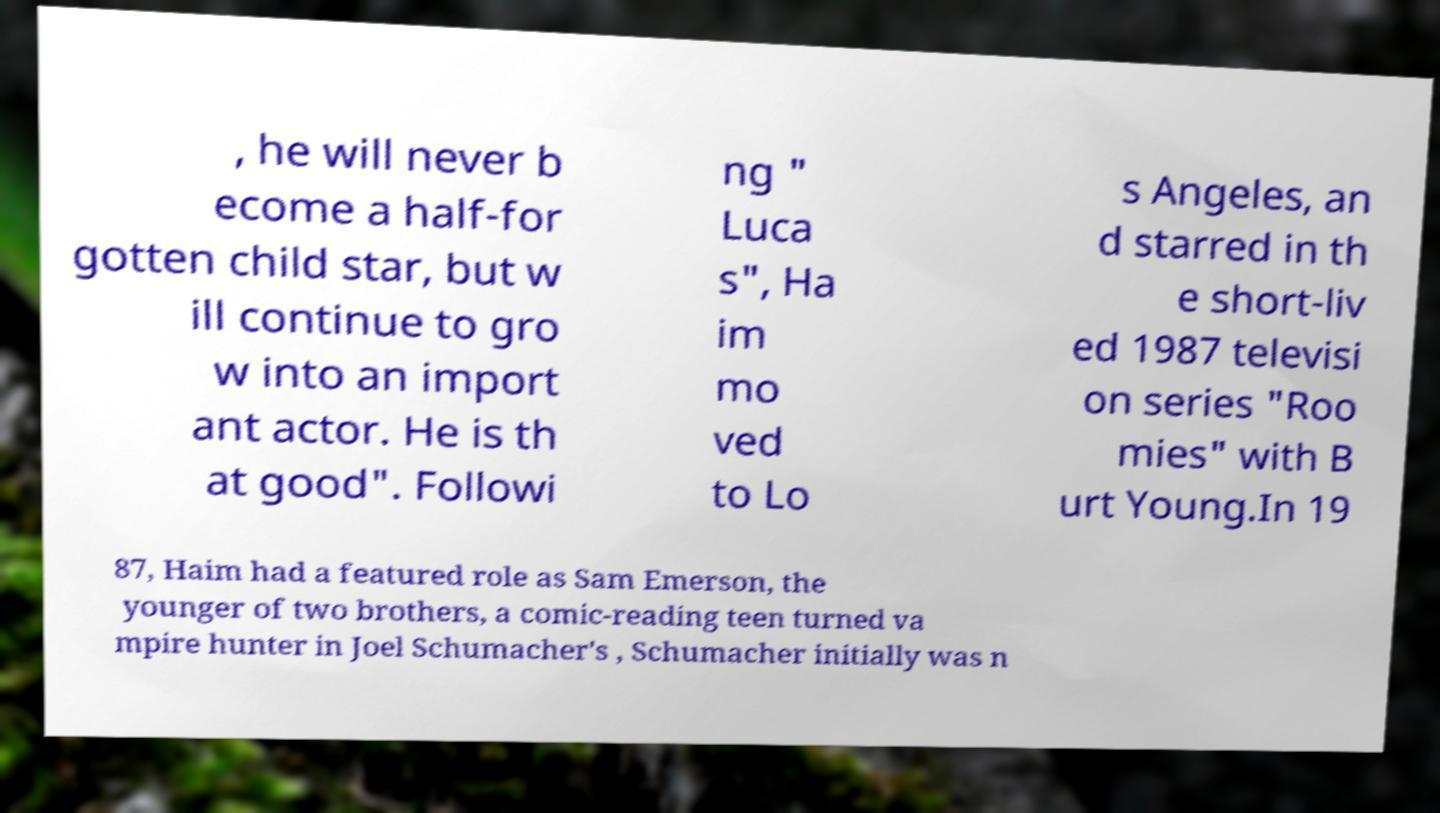Please identify and transcribe the text found in this image. , he will never b ecome a half-for gotten child star, but w ill continue to gro w into an import ant actor. He is th at good". Followi ng " Luca s", Ha im mo ved to Lo s Angeles, an d starred in th e short-liv ed 1987 televisi on series "Roo mies" with B urt Young.In 19 87, Haim had a featured role as Sam Emerson, the younger of two brothers, a comic-reading teen turned va mpire hunter in Joel Schumacher's , Schumacher initially was n 